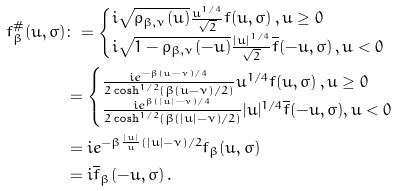Convert formula to latex. <formula><loc_0><loc_0><loc_500><loc_500>f _ { \beta } ^ { \# } ( u , \sigma ) & \colon = \begin{cases} i \sqrt { \rho _ { \beta , \nu } ( u ) } \frac { u ^ { 1 / 4 } } { \sqrt { 2 } } f ( u , \sigma ) \, , u \geq 0 \\ i \sqrt { 1 - \rho _ { \beta , \nu } ( - u ) } \frac { | u | ^ { 1 / 4 } } { \sqrt { 2 } } \overline { f } ( - u , \sigma ) \, , u < 0 \end{cases} \\ & = \begin{cases} \frac { i e ^ { - \beta ( u - \nu ) / 4 } } { 2 \cosh ^ { 1 / 2 } ( \beta ( u - \nu ) / 2 ) } u ^ { 1 / 4 } f ( u , \sigma ) \, , u \geq 0 \\ \frac { i e ^ { \beta ( | u | - \nu ) / 4 } } { 2 \cosh ^ { 1 / 2 } ( \beta ( | u | - \nu ) / 2 ) } | u | ^ { 1 / 4 } \overline { f } ( - u , \sigma ) , u < 0 \end{cases} \\ & = i e ^ { - \beta \frac { | u | } { u } ( | u | - \nu ) / 2 } f _ { \beta } ( u , \sigma ) \\ & = i \overline { f } _ { \beta } ( - u , \sigma ) \, .</formula> 